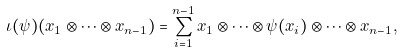Convert formula to latex. <formula><loc_0><loc_0><loc_500><loc_500>\iota ( \psi ) ( x _ { 1 } \otimes \dots \otimes x _ { n - 1 } ) = \sum _ { i = 1 } ^ { n - 1 } x _ { 1 } \otimes \dots \otimes \psi ( x _ { i } ) \otimes \dots \otimes x _ { n - 1 } ,</formula> 